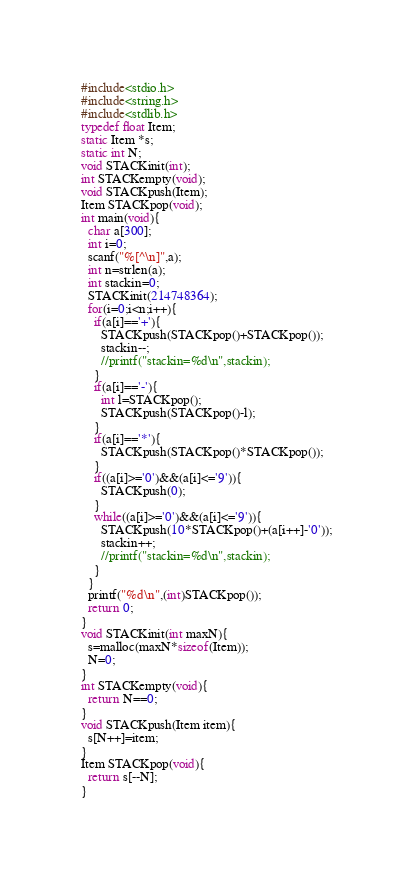<code> <loc_0><loc_0><loc_500><loc_500><_C_>#include<stdio.h>
#include<string.h>
#include<stdlib.h>
typedef float Item;
static Item *s;
static int N;
void STACKinit(int);
int STACKempty(void);
void STACKpush(Item);
Item STACKpop(void);
int main(void){
  char a[300];
  int i=0;
  scanf("%[^\n]",a);
  int n=strlen(a);
  int stackin=0;
  STACKinit(214748364);
  for(i=0;i<n;i++){
    if(a[i]=='+'){
      STACKpush(STACKpop()+STACKpop());
      stackin--;
      //printf("stackin=%d\n",stackin);
    }
    if(a[i]=='-'){
      int l=STACKpop();
      STACKpush(STACKpop()-l);
    }
    if(a[i]=='*'){
      STACKpush(STACKpop()*STACKpop());
    }
    if((a[i]>='0')&&(a[i]<='9')){
      STACKpush(0);
    }
    while((a[i]>='0')&&(a[i]<='9')){
      STACKpush(10*STACKpop()+(a[i++]-'0'));
      stackin++;
      //printf("stackin=%d\n",stackin);
    }
  }
  printf("%d\n",(int)STACKpop());
  return 0;
}
void STACKinit(int maxN){
  s=malloc(maxN*sizeof(Item));
  N=0;
}
int STACKempty(void){
  return N==0;
}
void STACKpush(Item item){
  s[N++]=item;
}
Item STACKpop(void){
  return s[--N];
}</code> 